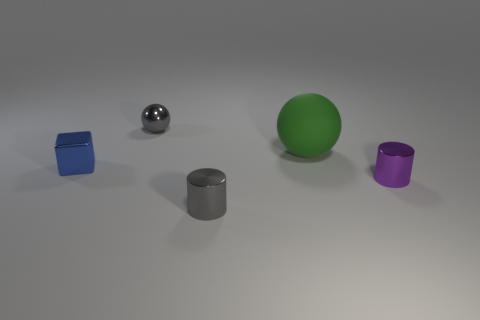Subtract all green spheres. How many spheres are left? 1 Add 1 big green metal objects. How many objects exist? 6 Subtract all brown cylinders. Subtract all gray blocks. How many cylinders are left? 2 Subtract all cylinders. How many objects are left? 3 Subtract all blue balls. How many purple cylinders are left? 1 Subtract all metal balls. Subtract all small purple shiny cylinders. How many objects are left? 3 Add 3 gray things. How many gray things are left? 5 Add 5 big blue metallic balls. How many big blue metallic balls exist? 5 Subtract 0 red cubes. How many objects are left? 5 